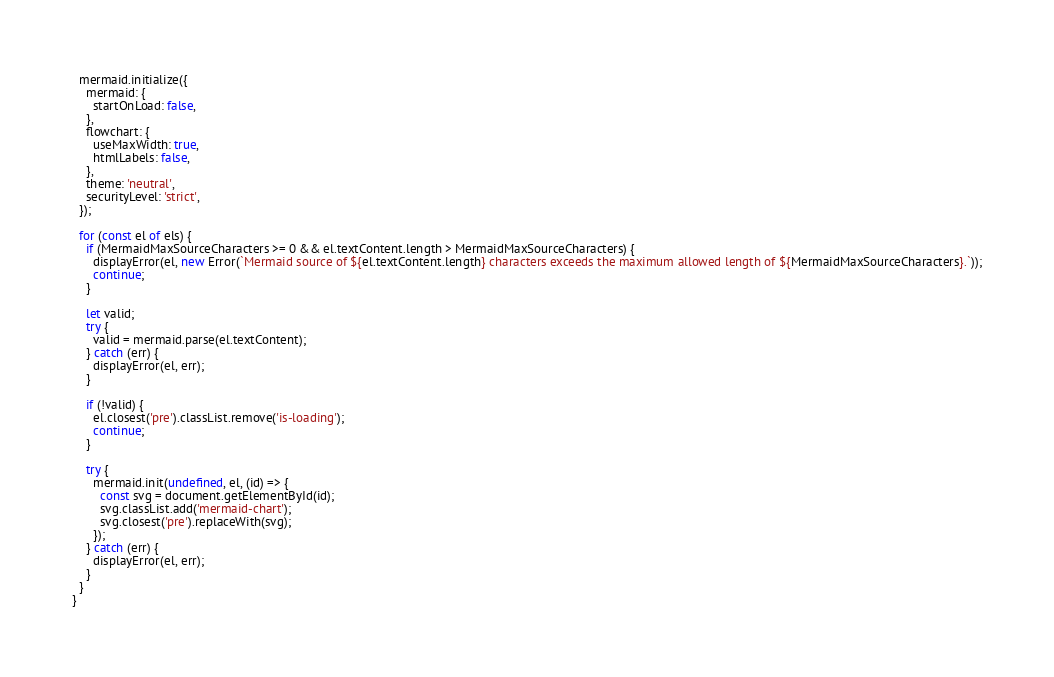Convert code to text. <code><loc_0><loc_0><loc_500><loc_500><_JavaScript_>  mermaid.initialize({
    mermaid: {
      startOnLoad: false,
    },
    flowchart: {
      useMaxWidth: true,
      htmlLabels: false,
    },
    theme: 'neutral',
    securityLevel: 'strict',
  });

  for (const el of els) {
    if (MermaidMaxSourceCharacters >= 0 && el.textContent.length > MermaidMaxSourceCharacters) {
      displayError(el, new Error(`Mermaid source of ${el.textContent.length} characters exceeds the maximum allowed length of ${MermaidMaxSourceCharacters}.`));
      continue;
    }

    let valid;
    try {
      valid = mermaid.parse(el.textContent);
    } catch (err) {
      displayError(el, err);
    }

    if (!valid) {
      el.closest('pre').classList.remove('is-loading');
      continue;
    }

    try {
      mermaid.init(undefined, el, (id) => {
        const svg = document.getElementById(id);
        svg.classList.add('mermaid-chart');
        svg.closest('pre').replaceWith(svg);
      });
    } catch (err) {
      displayError(el, err);
    }
  }
}
</code> 